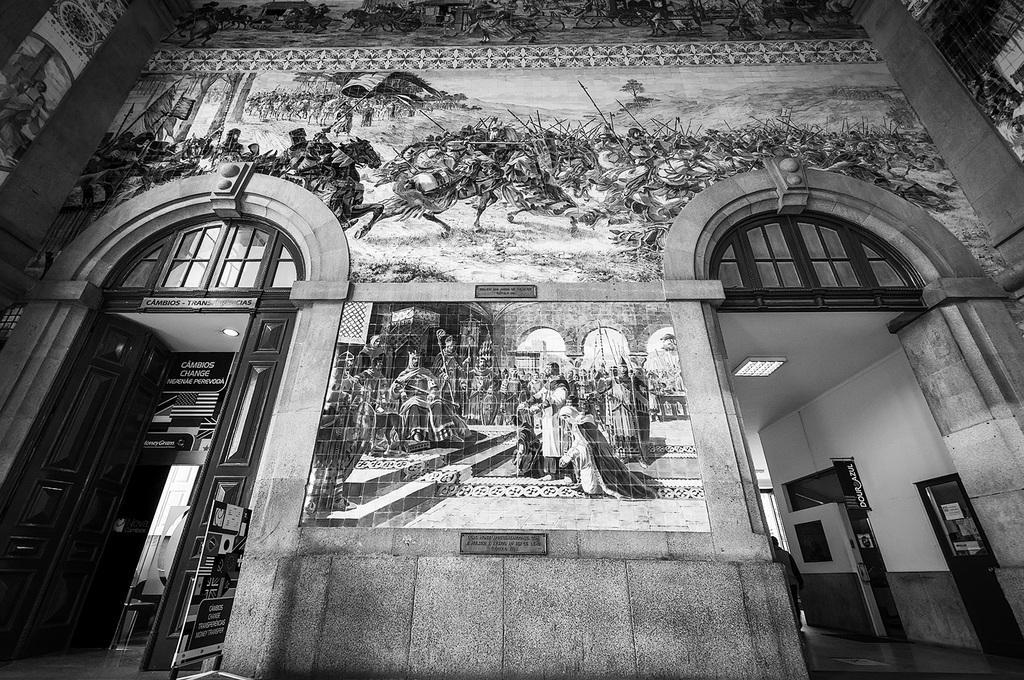How would you summarize this image in a sentence or two? In this image I can see a door, a wall and on this wall I can see an art. I can see this image is black and white in colour. 